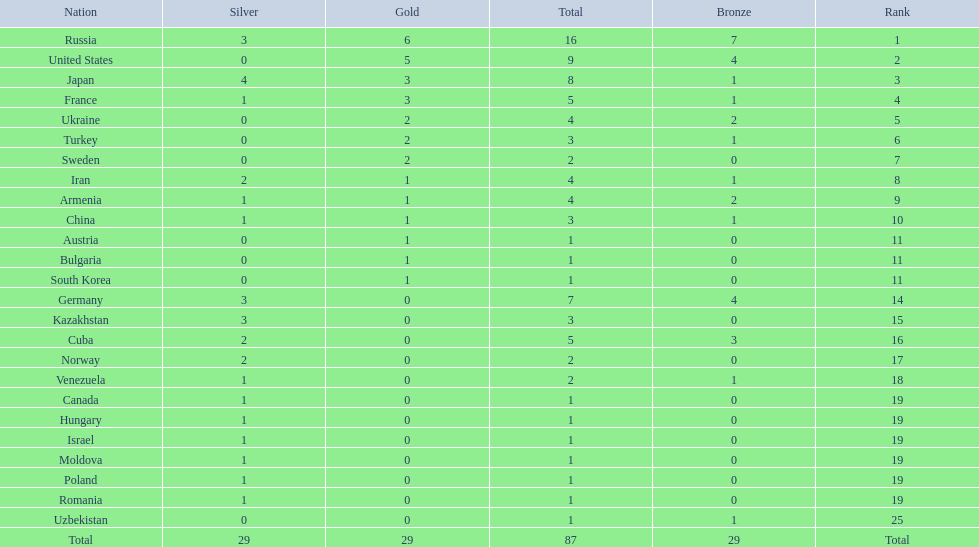Which country won only one medal, a bronze medal? Uzbekistan. 